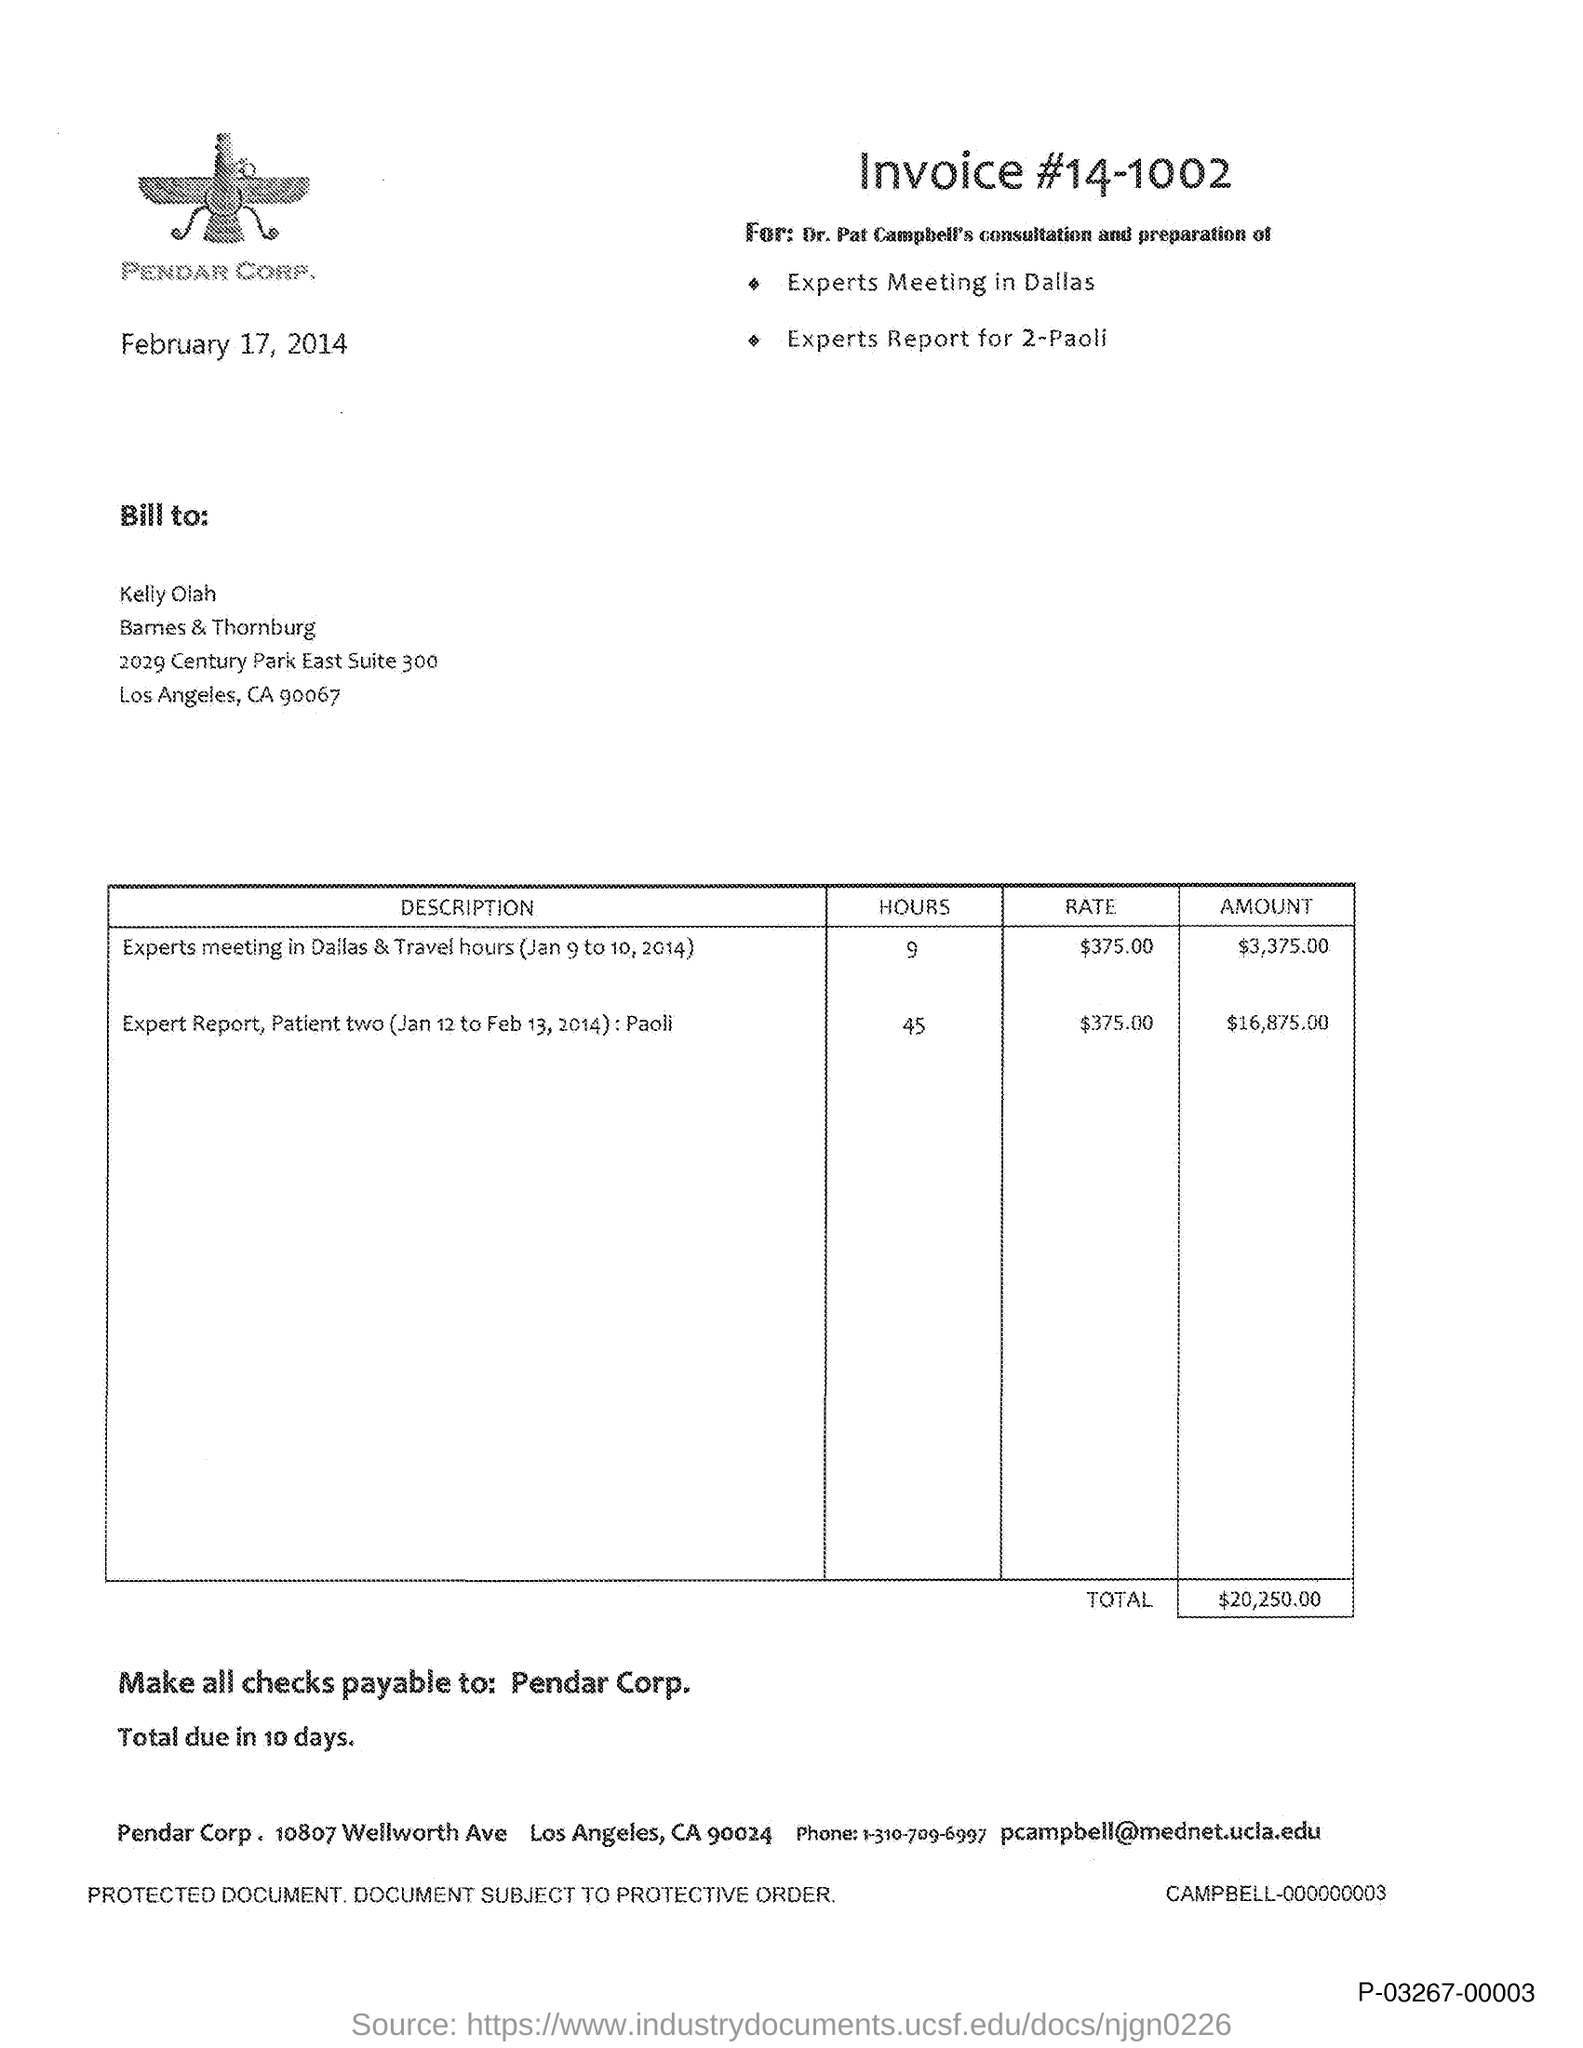What is the invoice # mentioned in the document?
Make the answer very short. 14-1002. What is the total amount of the invoice?
Make the answer very short. $20,250.00. To which company, the checks are payable?
Your answer should be very brief. Pendar Corp. What is the issued date of the invoice?
Your response must be concise. February 17, 2014. What is the email id of Pendar Corp.?
Your response must be concise. Pcampbell@mednet.ucla.edu. 